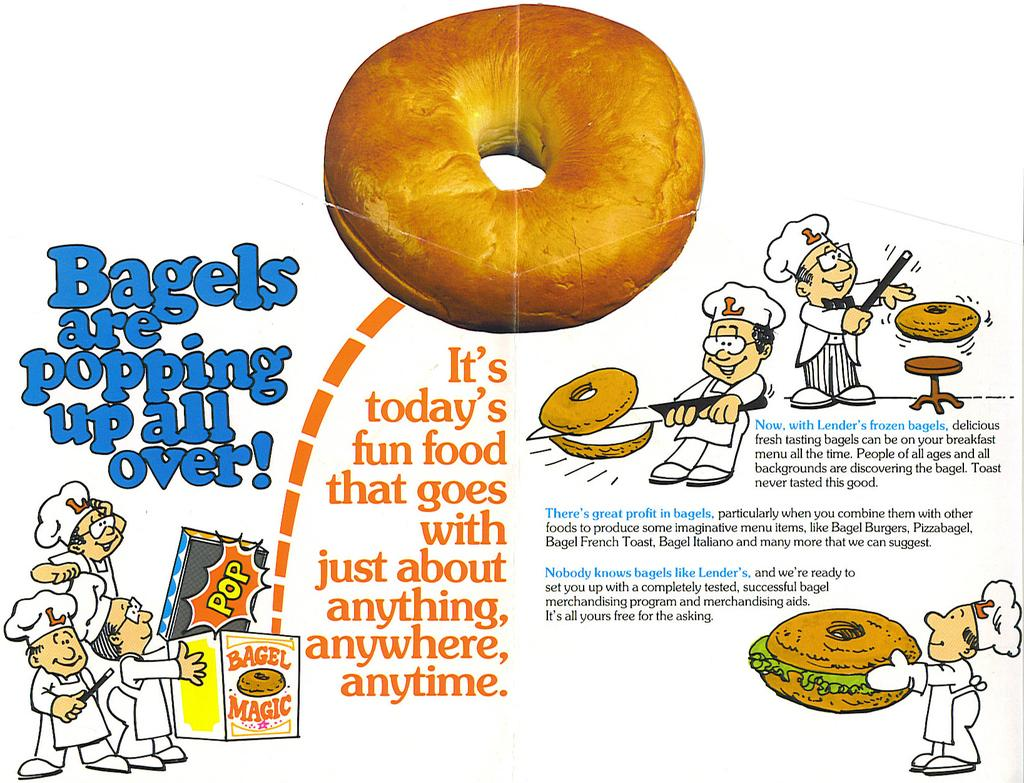What type of visual is the image? The image is a poster. What is the main subject of the poster? There is a doughnut depicted on the poster. What is the style of the images on the poster? There are animated pictures on the poster. What is the chance of winning a prize with the doughnut depicted on the poster? There is no information about winning a prize or any contest related to the doughnut in the image. 